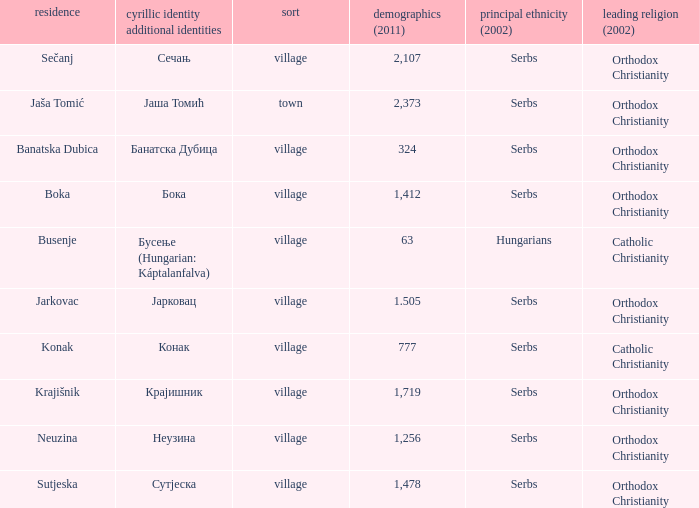Would you mind parsing the complete table? {'header': ['residence', 'cyrillic identity additional identities', 'sort', 'demographics (2011)', 'principal ethnicity (2002)', 'leading religion (2002)'], 'rows': [['Sečanj', 'Сечањ', 'village', '2,107', 'Serbs', 'Orthodox Christianity'], ['Jaša Tomić', 'Јаша Томић', 'town', '2,373', 'Serbs', 'Orthodox Christianity'], ['Banatska Dubica', 'Банатска Дубица', 'village', '324', 'Serbs', 'Orthodox Christianity'], ['Boka', 'Бока', 'village', '1,412', 'Serbs', 'Orthodox Christianity'], ['Busenje', 'Бусење (Hungarian: Káptalanfalva)', 'village', '63', 'Hungarians', 'Catholic Christianity'], ['Jarkovac', 'Јарковац', 'village', '1.505', 'Serbs', 'Orthodox Christianity'], ['Konak', 'Конак', 'village', '777', 'Serbs', 'Catholic Christianity'], ['Krajišnik', 'Крајишник', 'village', '1,719', 'Serbs', 'Orthodox Christianity'], ['Neuzina', 'Неузина', 'village', '1,256', 'Serbs', 'Orthodox Christianity'], ['Sutjeska', 'Сутјеска', 'village', '1,478', 'Serbs', 'Orthodox Christianity']]} The pooulation of јарковац is? 1.505. 